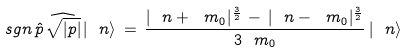Convert formula to latex. <formula><loc_0><loc_0><loc_500><loc_500>\ s g n \, \hat { p } \, \widehat { \sqrt { | p | } } \, | \ n \rangle \, = \, \frac { | \ n + \ m _ { 0 } | ^ { \frac { 3 } { 2 } } \, - \, | \ n - \ m _ { 0 } | ^ { \frac { 3 } { 2 } } } { 3 \ m _ { 0 } } \, | \ n \rangle</formula> 